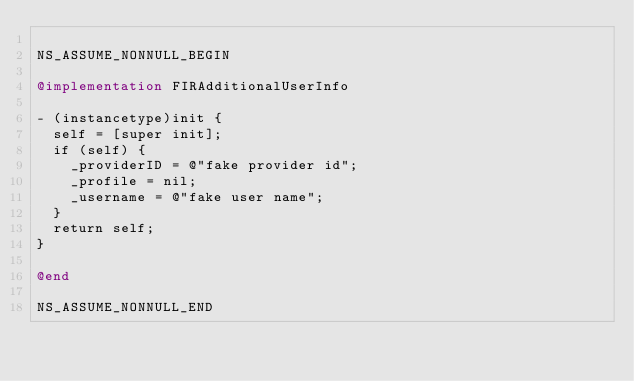Convert code to text. <code><loc_0><loc_0><loc_500><loc_500><_ObjectiveC_>
NS_ASSUME_NONNULL_BEGIN

@implementation FIRAdditionalUserInfo

- (instancetype)init {
  self = [super init];
  if (self) {
    _providerID = @"fake provider id";
    _profile = nil;
    _username = @"fake user name";
  }
  return self;
}

@end

NS_ASSUME_NONNULL_END
</code> 